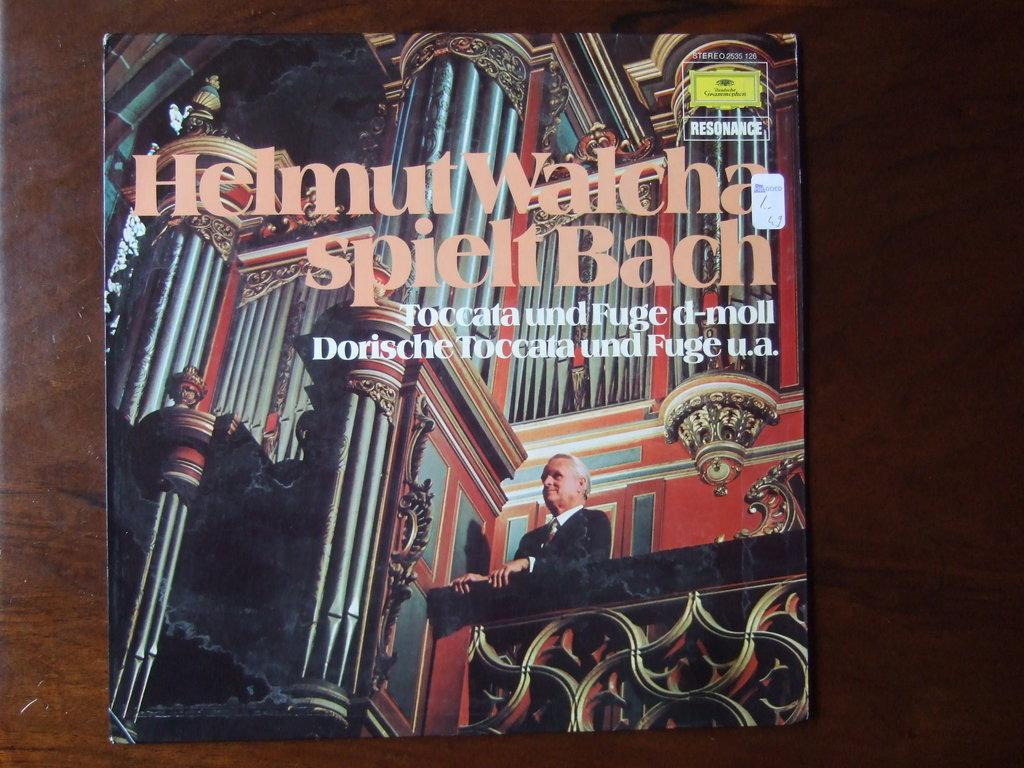<image>
Describe the image concisely. The album artwork for Helmut Walcha spielt Bach features a man in a black suit. 